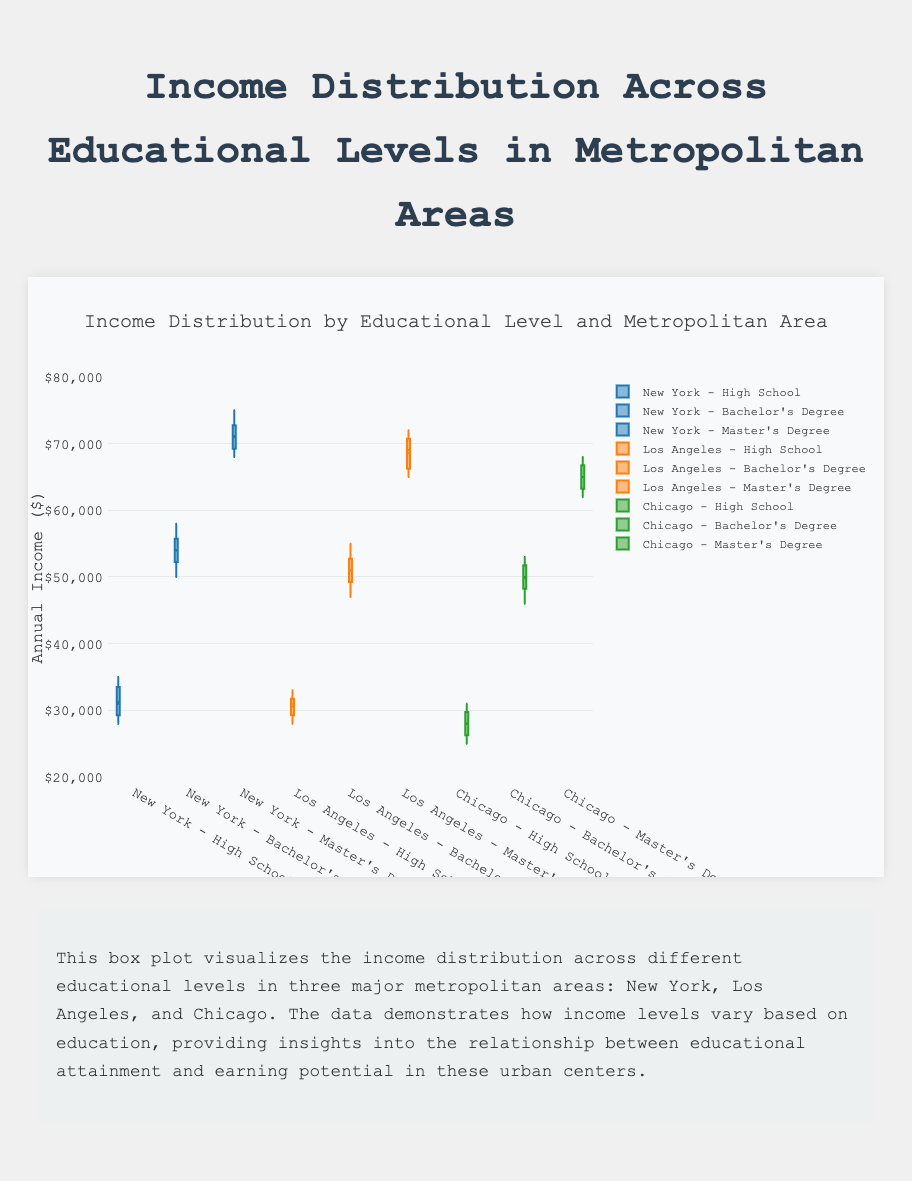What's the title of the figure? The title is usually placed at the top of the figure and describes what the figure represents. In this case, the figure's title is "Income Distribution by Educational Level and Metropolitan Area," which summarizes the contents of the plot.
Answer: Income Distribution by Educational Level and Metropolitan Area Which educational level has the highest median income in New York? In New York, identify the box corresponding to each educational level and compare their median lines. The educational level with the highest median line is “Master's Degree.”
Answer: Master's Degree What is the interquartile range (IQR) for the Bachelor’s Degree income distribution in Los Angeles? The IQR is the difference between the third quartile (Q3) and the first quartile (Q1) in the box plot. For Los Angeles Bachelor’s Degree, Q3 is 53000 and Q1 is 49000. Thus, IQR = 53000 - 49000.
Answer: 4000 Which metropolitan area and educational level combination has the lowest maximum income? Assess the top whisker end for each box to determine the highest income point. The lowest maximum income is observed for "High School" in Chicago.
Answer: High School in Chicago Which educational level in New York has the smallest spread in incomes? The spread in a box plot is shown by the range from the bottom to the top whisker. For New York, the Bachelor's Degree has the smallest spread (50000 to 58000).
Answer: Bachelor's Degree Compare the median incomes between Master’s Degree holders in Los Angeles and Chicago. Which metropolitan area has a higher median income? Locate and compare the median lines of the Master’s Degree box plots for Los Angeles and Chicago. The median income is higher in Los Angeles (67000) compared to Chicago (65000).
Answer: Los Angeles Is the distribution of incomes among Bachelor’s Degree holders in Chicago skewed, and if so, in which direction? A box plot's skew is visible by the position of the median within the box. For Chicago, the Bachelor's Degree box plot shows the median closer to the lower quartile, indicating a right skew.
Answer: Right-skewed Do Master's Degree holders in any area show any outliers, and if so, which metropolitan area and what are the outlier values? Outliers in a box plot are marked by points outside the whiskers. For Master's Degree, New York shows no outliers, Los Angeles no outliers, and Chicago no outliers, so none have outliers.
Answer: None Which metropolitan area shows the most variation in income for High School graduates? The most variation is indicated by the largest spread between the whiskers. For High School graduates, New York shows the most variation from 28000 to 35000.
Answer: New York 